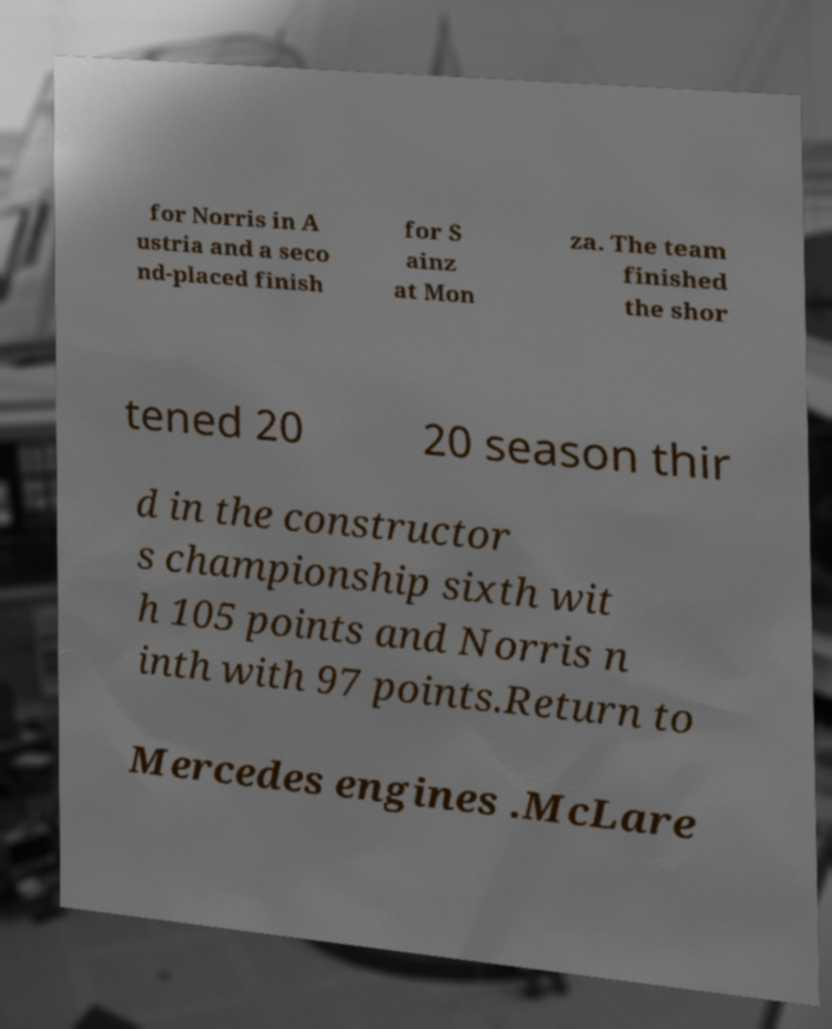There's text embedded in this image that I need extracted. Can you transcribe it verbatim? for Norris in A ustria and a seco nd-placed finish for S ainz at Mon za. The team finished the shor tened 20 20 season thir d in the constructor s championship sixth wit h 105 points and Norris n inth with 97 points.Return to Mercedes engines .McLare 